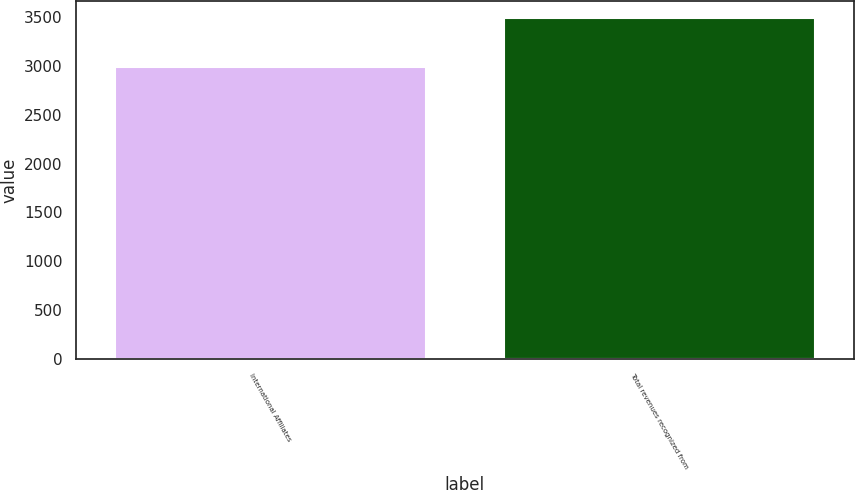Convert chart. <chart><loc_0><loc_0><loc_500><loc_500><bar_chart><fcel>International Affiliates<fcel>Total revenues recognized from<nl><fcel>2983<fcel>3492<nl></chart> 